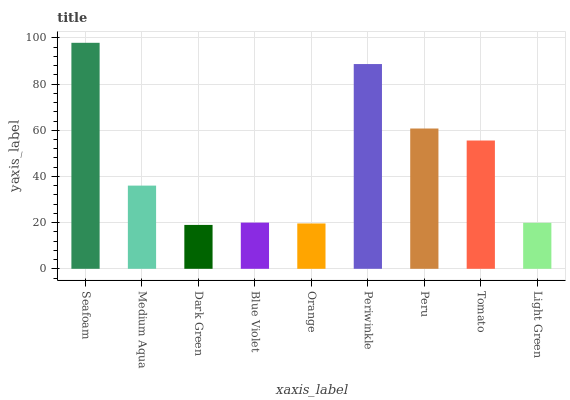Is Medium Aqua the minimum?
Answer yes or no. No. Is Medium Aqua the maximum?
Answer yes or no. No. Is Seafoam greater than Medium Aqua?
Answer yes or no. Yes. Is Medium Aqua less than Seafoam?
Answer yes or no. Yes. Is Medium Aqua greater than Seafoam?
Answer yes or no. No. Is Seafoam less than Medium Aqua?
Answer yes or no. No. Is Medium Aqua the high median?
Answer yes or no. Yes. Is Medium Aqua the low median?
Answer yes or no. Yes. Is Peru the high median?
Answer yes or no. No. Is Peru the low median?
Answer yes or no. No. 